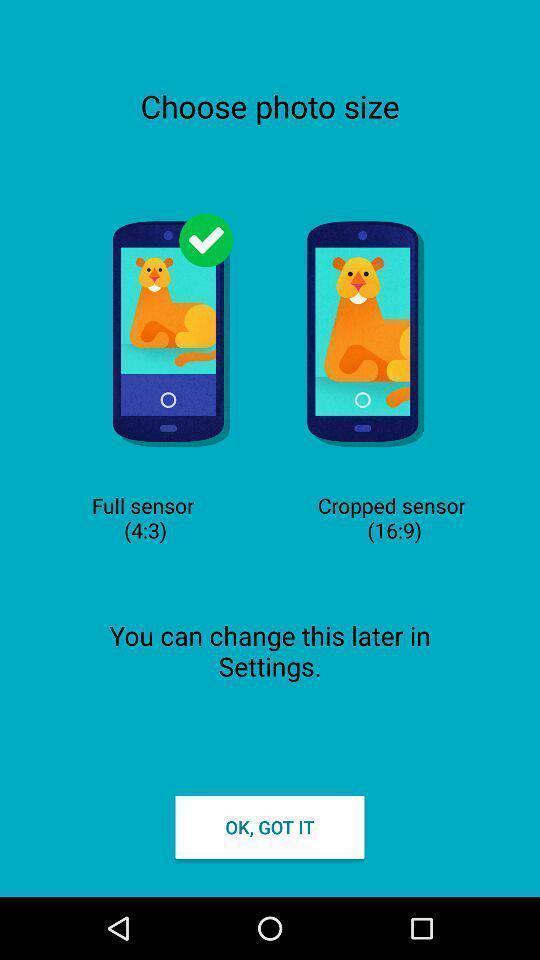Give me a summary of this screen capture. Set up page of camera app with options. Please provide a description for this image. Page showing option like ok got it. 